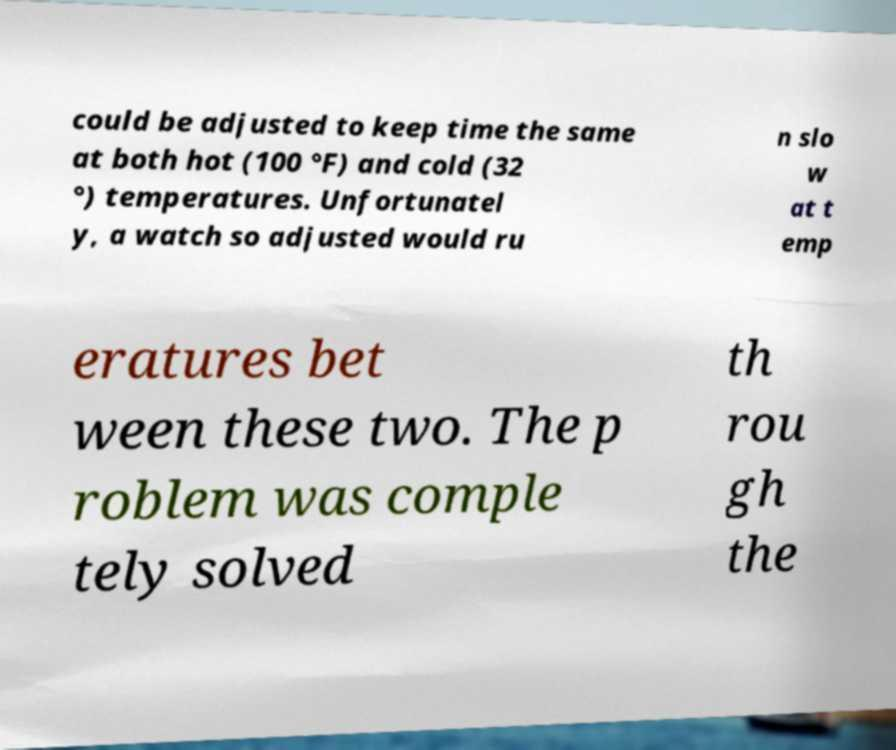Please identify and transcribe the text found in this image. could be adjusted to keep time the same at both hot (100 °F) and cold (32 °) temperatures. Unfortunatel y, a watch so adjusted would ru n slo w at t emp eratures bet ween these two. The p roblem was comple tely solved th rou gh the 